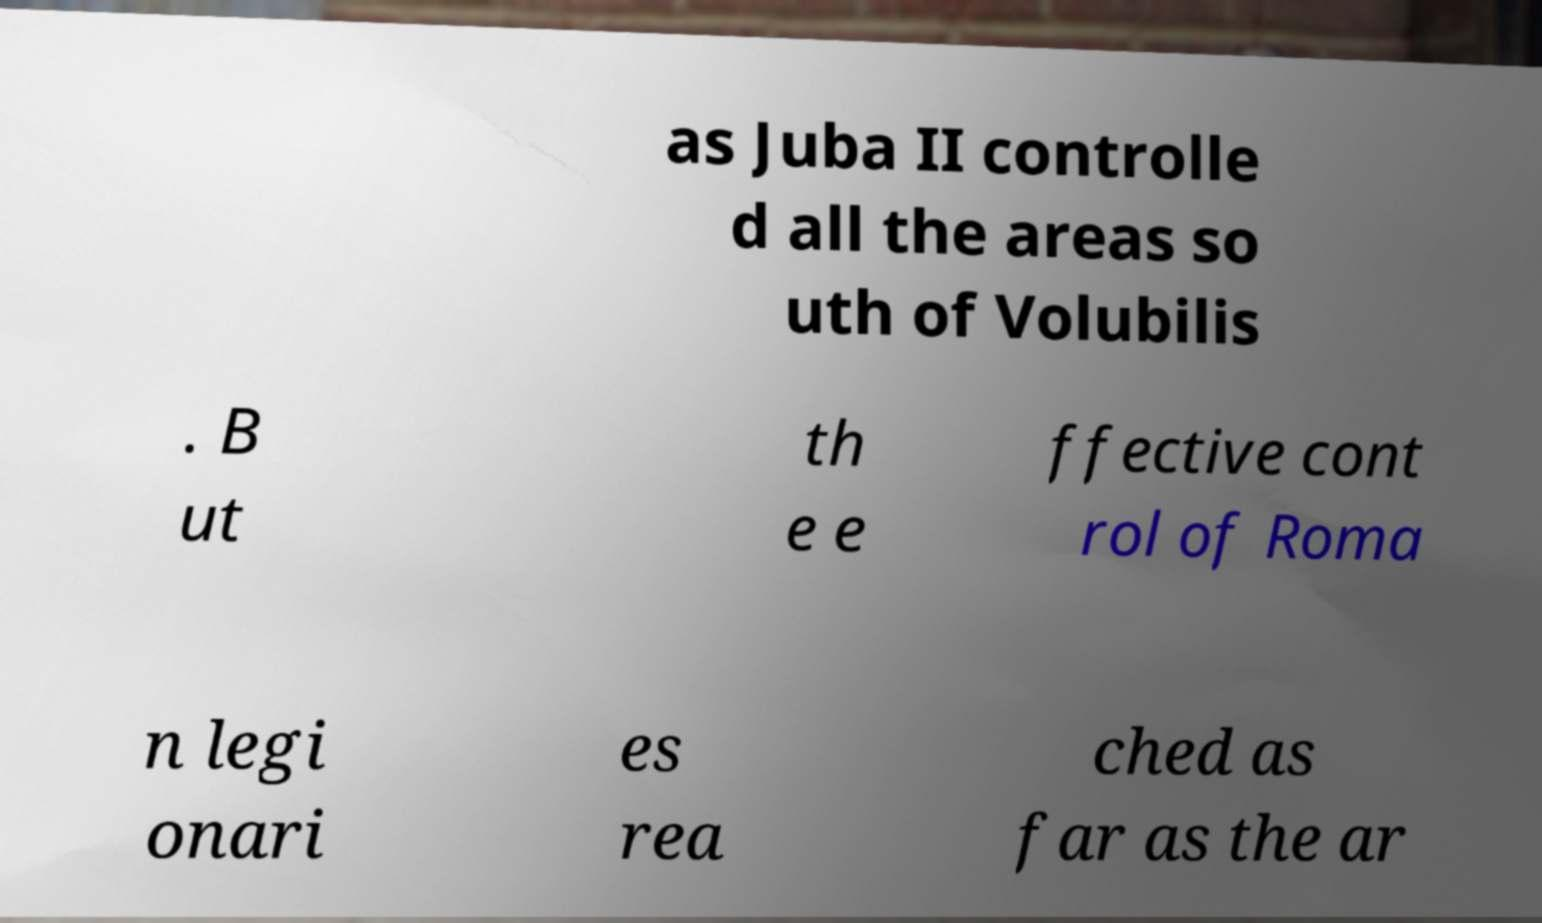There's text embedded in this image that I need extracted. Can you transcribe it verbatim? as Juba II controlle d all the areas so uth of Volubilis . B ut th e e ffective cont rol of Roma n legi onari es rea ched as far as the ar 